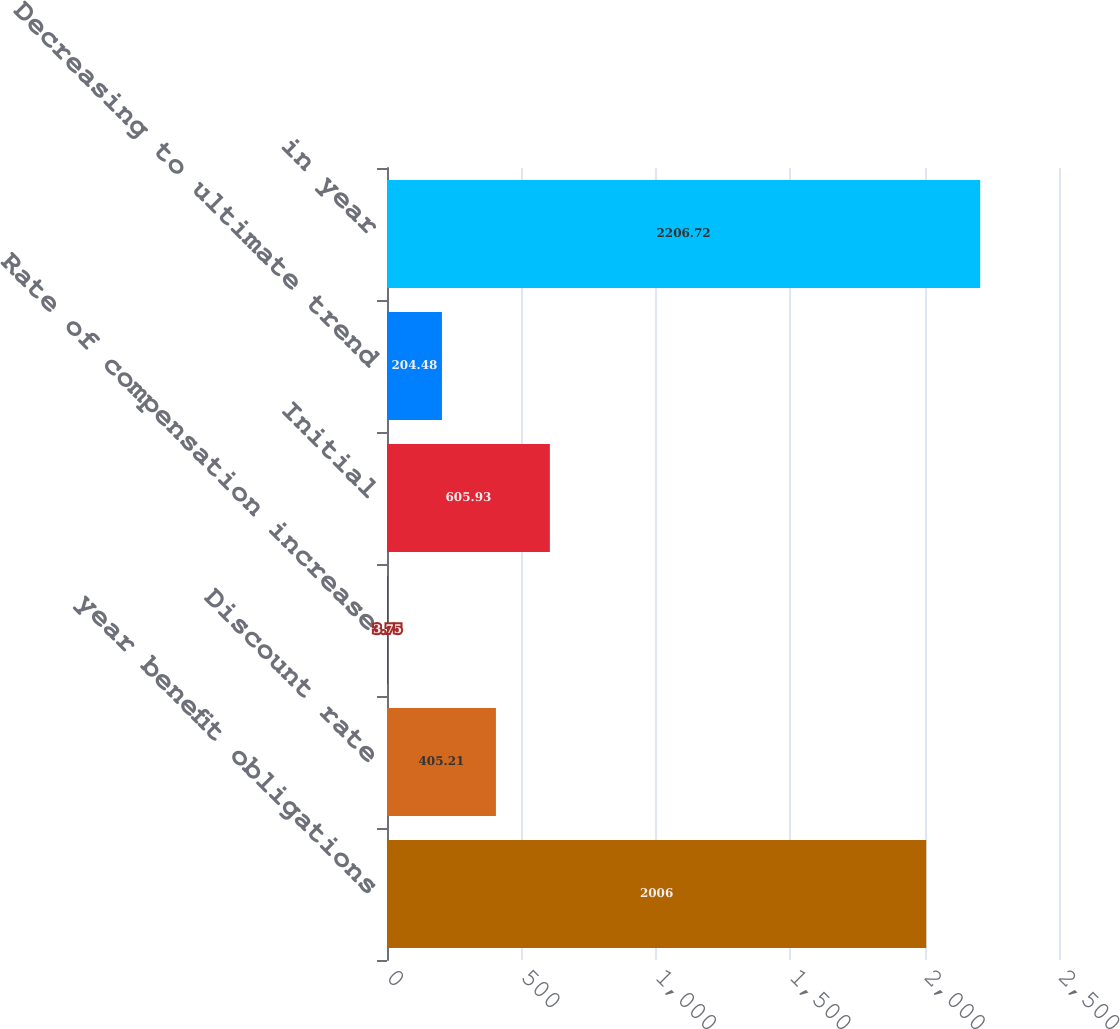<chart> <loc_0><loc_0><loc_500><loc_500><bar_chart><fcel>year benefit obligations<fcel>Discount rate<fcel>Rate of compensation increase<fcel>Initial<fcel>Decreasing to ultimate trend<fcel>in year<nl><fcel>2006<fcel>405.21<fcel>3.75<fcel>605.93<fcel>204.48<fcel>2206.72<nl></chart> 